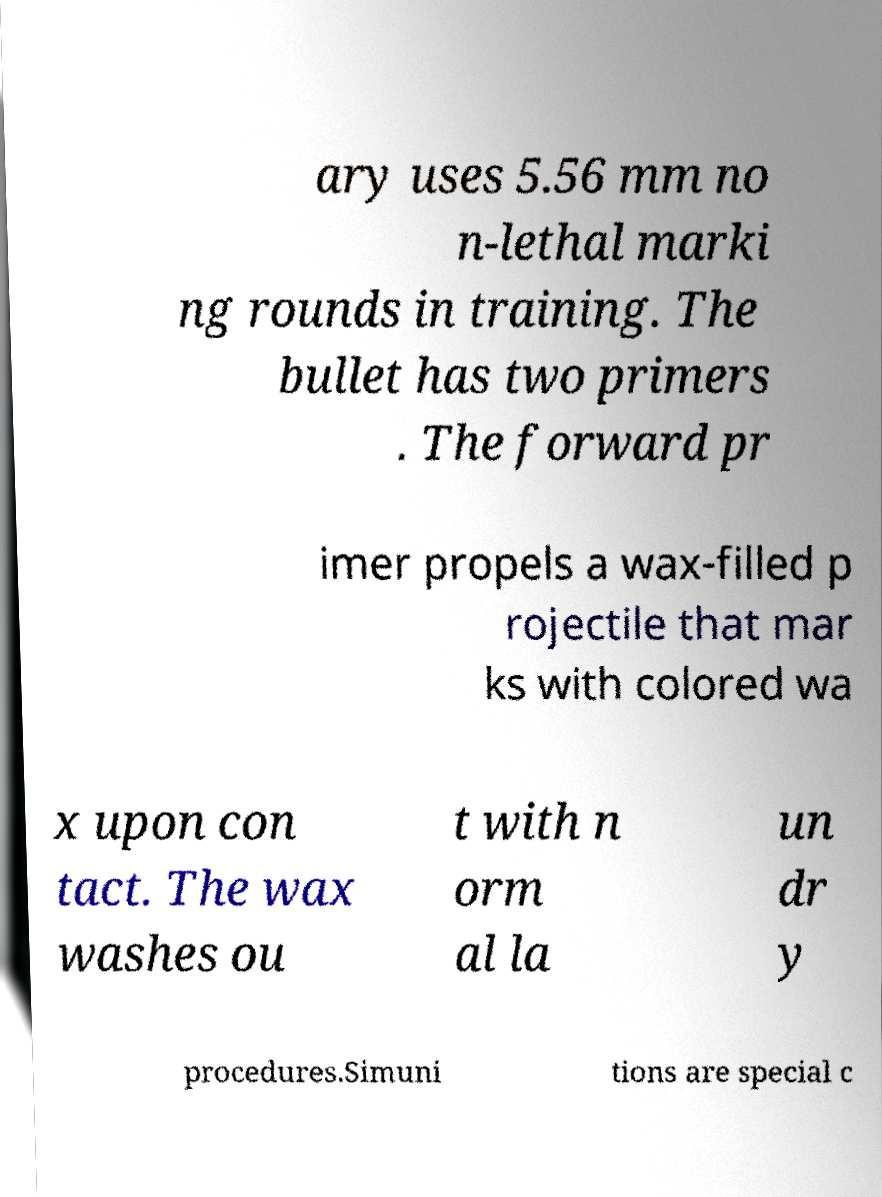Could you extract and type out the text from this image? ary uses 5.56 mm no n-lethal marki ng rounds in training. The bullet has two primers . The forward pr imer propels a wax-filled p rojectile that mar ks with colored wa x upon con tact. The wax washes ou t with n orm al la un dr y procedures.Simuni tions are special c 